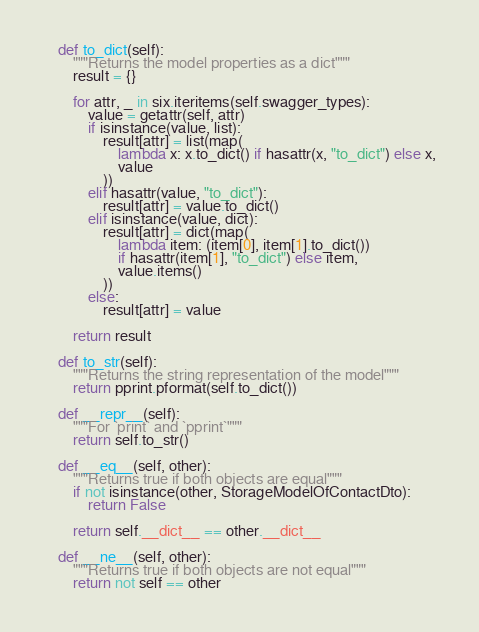Convert code to text. <code><loc_0><loc_0><loc_500><loc_500><_Python_>    def to_dict(self):
        """Returns the model properties as a dict"""
        result = {}

        for attr, _ in six.iteritems(self.swagger_types):
            value = getattr(self, attr)
            if isinstance(value, list):
                result[attr] = list(map(
                    lambda x: x.to_dict() if hasattr(x, "to_dict") else x,
                    value
                ))
            elif hasattr(value, "to_dict"):
                result[attr] = value.to_dict()
            elif isinstance(value, dict):
                result[attr] = dict(map(
                    lambda item: (item[0], item[1].to_dict())
                    if hasattr(item[1], "to_dict") else item,
                    value.items()
                ))
            else:
                result[attr] = value

        return result

    def to_str(self):
        """Returns the string representation of the model"""
        return pprint.pformat(self.to_dict())

    def __repr__(self):
        """For `print` and `pprint`"""
        return self.to_str()

    def __eq__(self, other):
        """Returns true if both objects are equal"""
        if not isinstance(other, StorageModelOfContactDto):
            return False

        return self.__dict__ == other.__dict__

    def __ne__(self, other):
        """Returns true if both objects are not equal"""
        return not self == other
</code> 